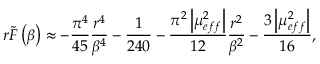Convert formula to latex. <formula><loc_0><loc_0><loc_500><loc_500>r \widetilde { F } \left ( \beta \right ) \approx - \frac { \pi ^ { 4 } } { 4 5 } \frac { r ^ { 4 } } { \beta ^ { 4 } } - \frac { 1 } { 2 4 0 } - \frac { \pi ^ { 2 } \left | \mu _ { e f f } ^ { 2 } \right | } { 1 2 } \frac { r ^ { 2 } } { \beta ^ { 2 } } - \frac { 3 \left | \mu _ { e f f } ^ { 2 } \right | } { 1 6 } ,</formula> 